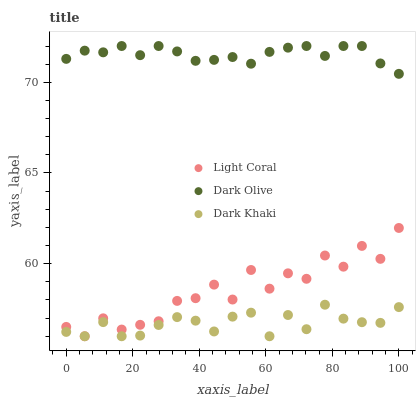Does Dark Khaki have the minimum area under the curve?
Answer yes or no. Yes. Does Dark Olive have the maximum area under the curve?
Answer yes or no. Yes. Does Dark Olive have the minimum area under the curve?
Answer yes or no. No. Does Dark Khaki have the maximum area under the curve?
Answer yes or no. No. Is Dark Olive the smoothest?
Answer yes or no. Yes. Is Light Coral the roughest?
Answer yes or no. Yes. Is Dark Khaki the smoothest?
Answer yes or no. No. Is Dark Khaki the roughest?
Answer yes or no. No. Does Light Coral have the lowest value?
Answer yes or no. Yes. Does Dark Olive have the lowest value?
Answer yes or no. No. Does Dark Olive have the highest value?
Answer yes or no. Yes. Does Dark Khaki have the highest value?
Answer yes or no. No. Is Dark Khaki less than Dark Olive?
Answer yes or no. Yes. Is Dark Olive greater than Dark Khaki?
Answer yes or no. Yes. Does Light Coral intersect Dark Khaki?
Answer yes or no. Yes. Is Light Coral less than Dark Khaki?
Answer yes or no. No. Is Light Coral greater than Dark Khaki?
Answer yes or no. No. Does Dark Khaki intersect Dark Olive?
Answer yes or no. No. 